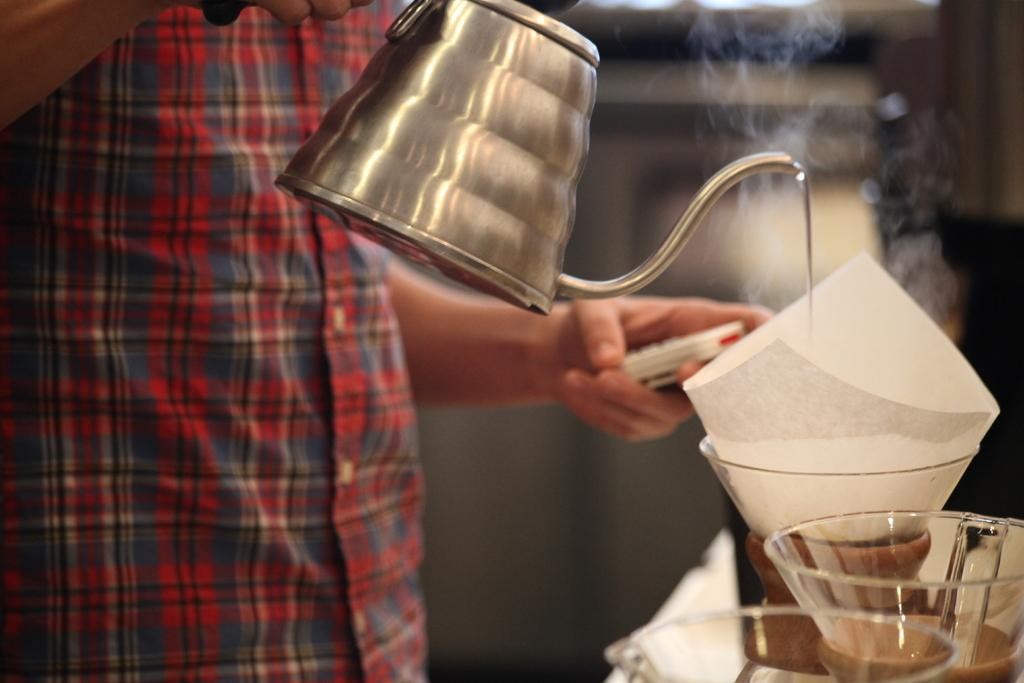Who is present in the image? There is a person in the image. What is the person holding in the image? The person is holding a kettle. What objects can be seen on the right side of the image? There are glasses and a paper on the right side of the image. Can you describe the background of the image? The background of the image is blurry. What type of watch can be seen on the person's wrist in the image? There is no watch visible on the person's wrist in the image. Is there any salt present in the image? There is no salt present in the image. 